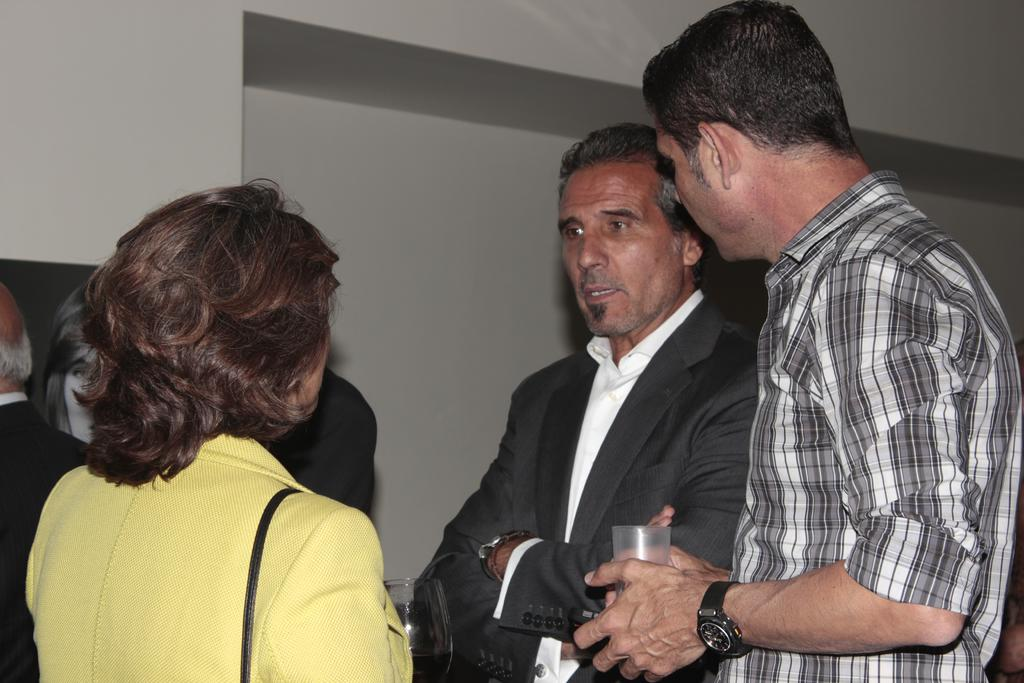What is happening in the image? There are people standing in the image. Can you describe what one of the people is holding? One man is holding a glass in his hand. What can be seen in the background of the image? There is a wall in the background of the image. What type of pancake is being served on the coat in the image? There is no pancake or coat present in the image. 